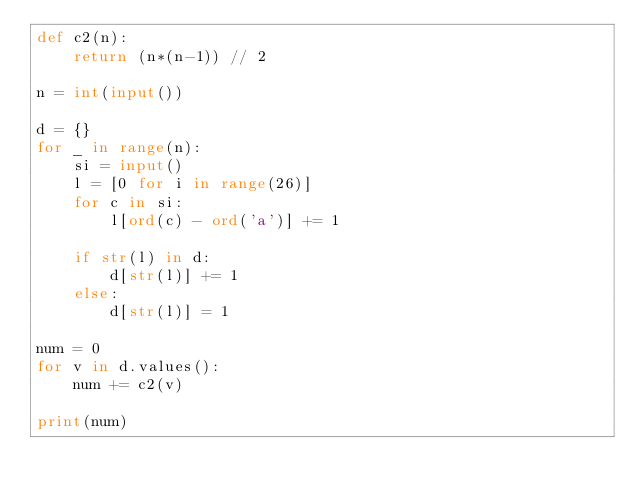<code> <loc_0><loc_0><loc_500><loc_500><_Python_>def c2(n):
    return (n*(n-1)) // 2

n = int(input())

d = {}
for _ in range(n):
    si = input()
    l = [0 for i in range(26)]
    for c in si:
        l[ord(c) - ord('a')] += 1

    if str(l) in d:
        d[str(l)] += 1
    else:
        d[str(l)] = 1

num = 0
for v in d.values():
    num += c2(v)

print(num)</code> 